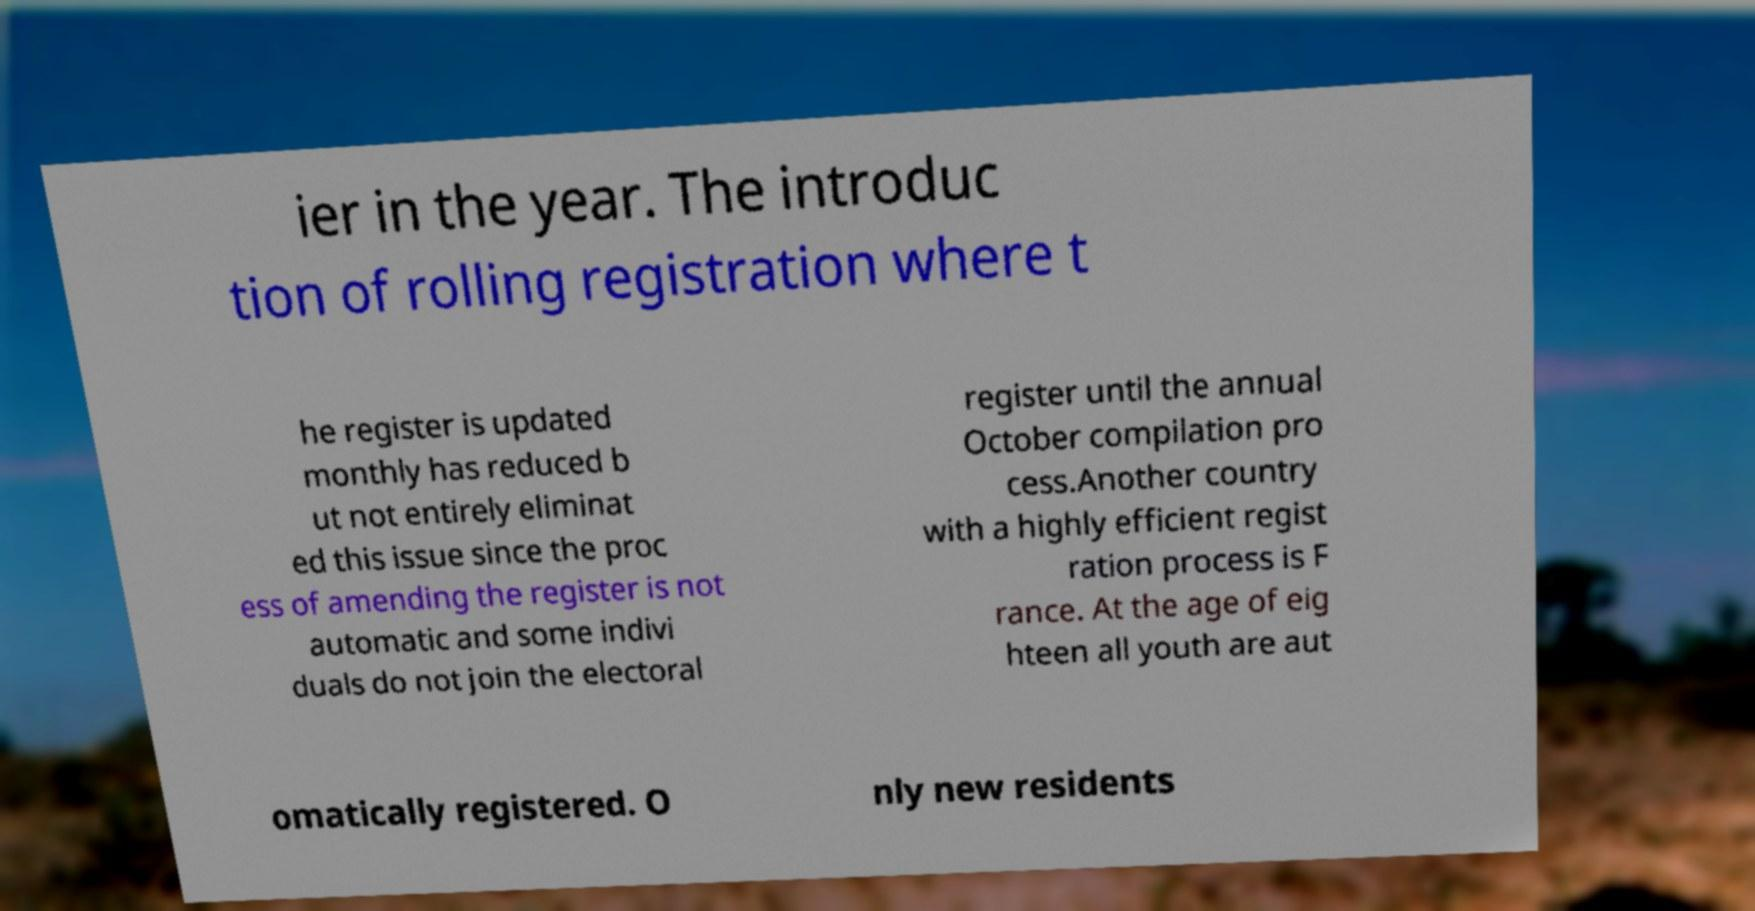Could you extract and type out the text from this image? ier in the year. The introduc tion of rolling registration where t he register is updated monthly has reduced b ut not entirely eliminat ed this issue since the proc ess of amending the register is not automatic and some indivi duals do not join the electoral register until the annual October compilation pro cess.Another country with a highly efficient regist ration process is F rance. At the age of eig hteen all youth are aut omatically registered. O nly new residents 